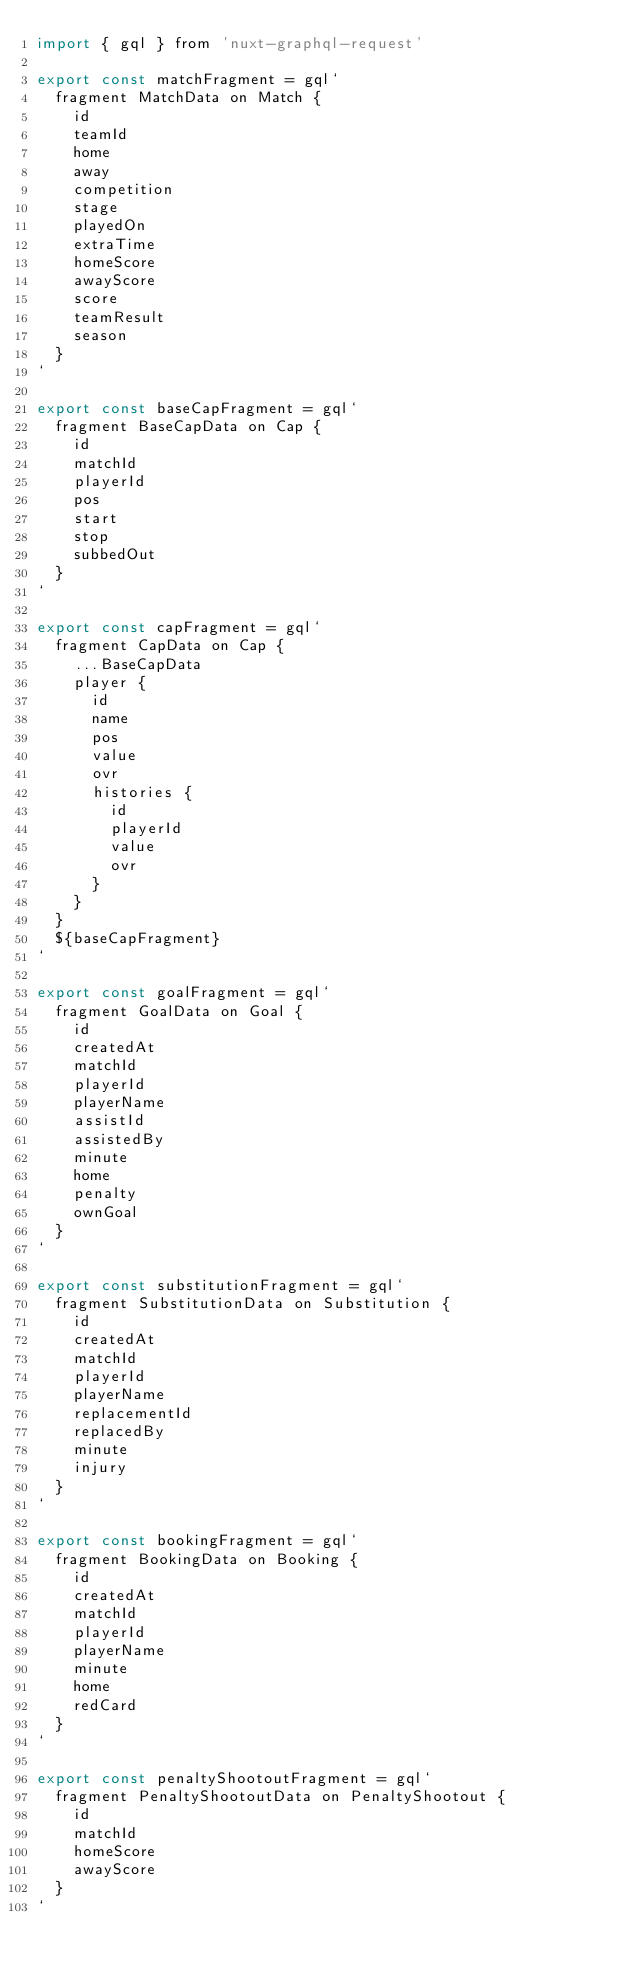Convert code to text. <code><loc_0><loc_0><loc_500><loc_500><_JavaScript_>import { gql } from 'nuxt-graphql-request'

export const matchFragment = gql`
  fragment MatchData on Match {
    id
    teamId
    home
    away
    competition
    stage
    playedOn
    extraTime
    homeScore
    awayScore
    score
    teamResult
    season
  }
`

export const baseCapFragment = gql`
  fragment BaseCapData on Cap {
    id
    matchId
    playerId
    pos
    start
    stop
    subbedOut
  }
`

export const capFragment = gql`
  fragment CapData on Cap {
    ...BaseCapData
    player {
      id
      name
      pos
      value
      ovr
      histories {
        id
        playerId
        value
        ovr
      }
    }
  }
  ${baseCapFragment}
`

export const goalFragment = gql`
  fragment GoalData on Goal {
    id
    createdAt
    matchId
    playerId
    playerName
    assistId
    assistedBy
    minute
    home
    penalty
    ownGoal
  }
`

export const substitutionFragment = gql`
  fragment SubstitutionData on Substitution {
    id
    createdAt
    matchId
    playerId
    playerName
    replacementId
    replacedBy
    minute
    injury
  }
`

export const bookingFragment = gql`
  fragment BookingData on Booking {
    id
    createdAt
    matchId
    playerId
    playerName
    minute
    home
    redCard
  }
`

export const penaltyShootoutFragment = gql`
  fragment PenaltyShootoutData on PenaltyShootout {
    id
    matchId
    homeScore
    awayScore
  }
`
</code> 